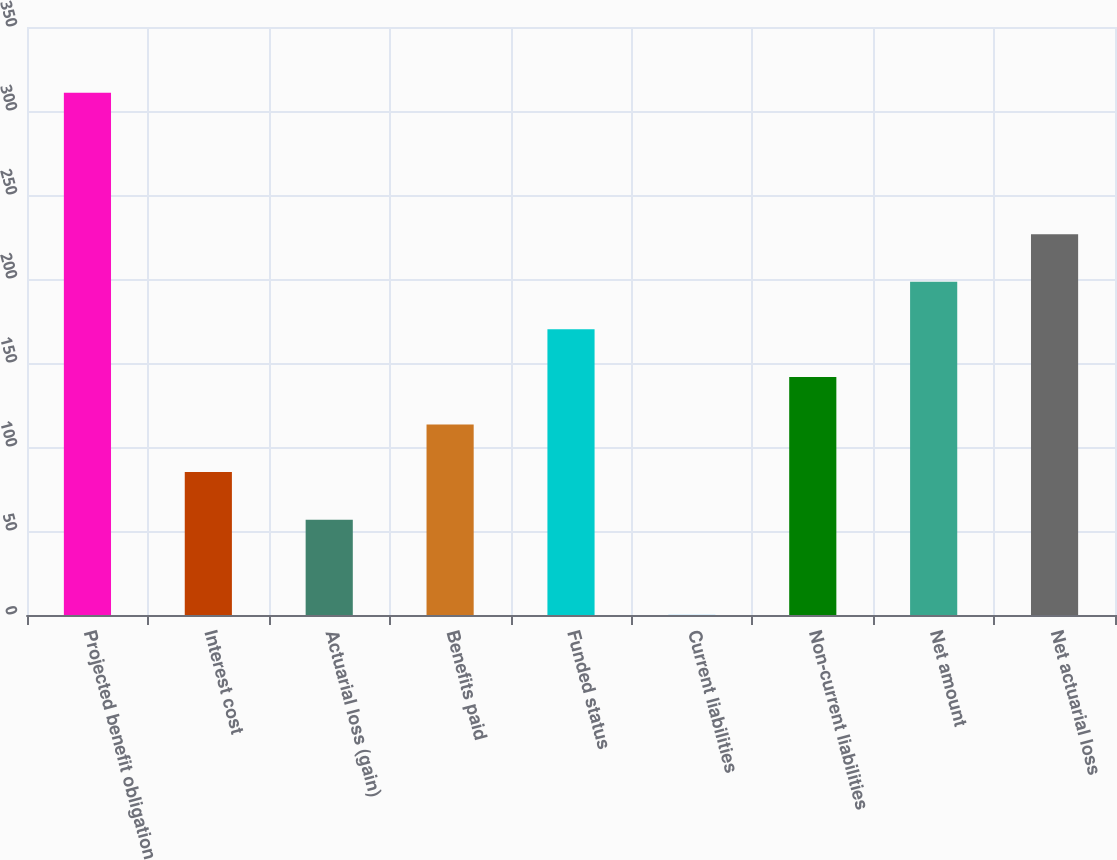Convert chart. <chart><loc_0><loc_0><loc_500><loc_500><bar_chart><fcel>Projected benefit obligation<fcel>Interest cost<fcel>Actuarial loss (gain)<fcel>Benefits paid<fcel>Funded status<fcel>Current liabilities<fcel>Non-current liabilities<fcel>Net amount<fcel>Net actuarial loss<nl><fcel>310.82<fcel>85.06<fcel>56.74<fcel>113.38<fcel>170.02<fcel>0.1<fcel>141.7<fcel>198.34<fcel>226.66<nl></chart> 